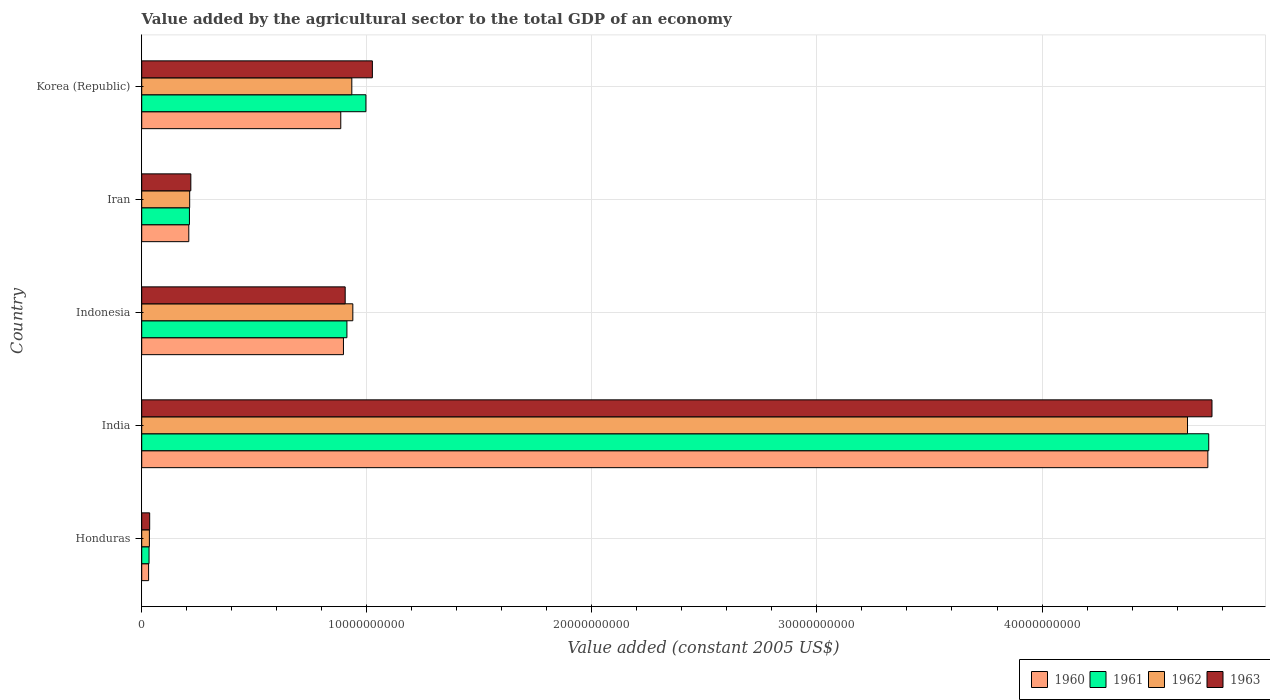Are the number of bars per tick equal to the number of legend labels?
Offer a terse response. Yes. Are the number of bars on each tick of the Y-axis equal?
Offer a terse response. Yes. How many bars are there on the 3rd tick from the top?
Your answer should be very brief. 4. What is the label of the 5th group of bars from the top?
Provide a short and direct response. Honduras. In how many cases, is the number of bars for a given country not equal to the number of legend labels?
Your answer should be very brief. 0. What is the value added by the agricultural sector in 1962 in Indonesia?
Your answer should be compact. 9.38e+09. Across all countries, what is the maximum value added by the agricultural sector in 1963?
Your answer should be compact. 4.76e+1. Across all countries, what is the minimum value added by the agricultural sector in 1963?
Keep it short and to the point. 3.53e+08. In which country was the value added by the agricultural sector in 1961 maximum?
Your response must be concise. India. In which country was the value added by the agricultural sector in 1961 minimum?
Your response must be concise. Honduras. What is the total value added by the agricultural sector in 1960 in the graph?
Your response must be concise. 6.76e+1. What is the difference between the value added by the agricultural sector in 1962 in India and that in Indonesia?
Offer a very short reply. 3.71e+1. What is the difference between the value added by the agricultural sector in 1961 in India and the value added by the agricultural sector in 1962 in Iran?
Offer a terse response. 4.53e+1. What is the average value added by the agricultural sector in 1961 per country?
Ensure brevity in your answer.  1.38e+1. What is the difference between the value added by the agricultural sector in 1960 and value added by the agricultural sector in 1962 in Honduras?
Offer a very short reply. -3.54e+07. What is the ratio of the value added by the agricultural sector in 1961 in Honduras to that in Korea (Republic)?
Give a very brief answer. 0.03. What is the difference between the highest and the second highest value added by the agricultural sector in 1960?
Your answer should be compact. 3.84e+1. What is the difference between the highest and the lowest value added by the agricultural sector in 1961?
Make the answer very short. 4.71e+1. In how many countries, is the value added by the agricultural sector in 1961 greater than the average value added by the agricultural sector in 1961 taken over all countries?
Your response must be concise. 1. What does the 2nd bar from the bottom in Indonesia represents?
Provide a succinct answer. 1961. Is it the case that in every country, the sum of the value added by the agricultural sector in 1960 and value added by the agricultural sector in 1961 is greater than the value added by the agricultural sector in 1963?
Keep it short and to the point. Yes. How many bars are there?
Your answer should be compact. 20. Are all the bars in the graph horizontal?
Provide a short and direct response. Yes. How many countries are there in the graph?
Make the answer very short. 5. Does the graph contain any zero values?
Make the answer very short. No. Does the graph contain grids?
Give a very brief answer. Yes. How many legend labels are there?
Offer a terse response. 4. How are the legend labels stacked?
Offer a terse response. Horizontal. What is the title of the graph?
Keep it short and to the point. Value added by the agricultural sector to the total GDP of an economy. What is the label or title of the X-axis?
Keep it short and to the point. Value added (constant 2005 US$). What is the Value added (constant 2005 US$) of 1960 in Honduras?
Your answer should be very brief. 3.05e+08. What is the Value added (constant 2005 US$) in 1961 in Honduras?
Your response must be concise. 3.25e+08. What is the Value added (constant 2005 US$) of 1962 in Honduras?
Ensure brevity in your answer.  3.41e+08. What is the Value added (constant 2005 US$) of 1963 in Honduras?
Provide a succinct answer. 3.53e+08. What is the Value added (constant 2005 US$) in 1960 in India?
Offer a terse response. 4.74e+1. What is the Value added (constant 2005 US$) of 1961 in India?
Give a very brief answer. 4.74e+1. What is the Value added (constant 2005 US$) of 1962 in India?
Provide a succinct answer. 4.65e+1. What is the Value added (constant 2005 US$) in 1963 in India?
Make the answer very short. 4.76e+1. What is the Value added (constant 2005 US$) of 1960 in Indonesia?
Provide a short and direct response. 8.96e+09. What is the Value added (constant 2005 US$) in 1961 in Indonesia?
Your answer should be very brief. 9.12e+09. What is the Value added (constant 2005 US$) in 1962 in Indonesia?
Ensure brevity in your answer.  9.38e+09. What is the Value added (constant 2005 US$) in 1963 in Indonesia?
Ensure brevity in your answer.  9.04e+09. What is the Value added (constant 2005 US$) of 1960 in Iran?
Your response must be concise. 2.09e+09. What is the Value added (constant 2005 US$) in 1961 in Iran?
Provide a short and direct response. 2.12e+09. What is the Value added (constant 2005 US$) in 1962 in Iran?
Offer a terse response. 2.13e+09. What is the Value added (constant 2005 US$) of 1963 in Iran?
Offer a very short reply. 2.18e+09. What is the Value added (constant 2005 US$) in 1960 in Korea (Republic)?
Provide a succinct answer. 8.84e+09. What is the Value added (constant 2005 US$) in 1961 in Korea (Republic)?
Make the answer very short. 9.96e+09. What is the Value added (constant 2005 US$) of 1962 in Korea (Republic)?
Give a very brief answer. 9.33e+09. What is the Value added (constant 2005 US$) in 1963 in Korea (Republic)?
Give a very brief answer. 1.02e+1. Across all countries, what is the maximum Value added (constant 2005 US$) of 1960?
Your answer should be very brief. 4.74e+1. Across all countries, what is the maximum Value added (constant 2005 US$) of 1961?
Give a very brief answer. 4.74e+1. Across all countries, what is the maximum Value added (constant 2005 US$) in 1962?
Give a very brief answer. 4.65e+1. Across all countries, what is the maximum Value added (constant 2005 US$) of 1963?
Provide a succinct answer. 4.76e+1. Across all countries, what is the minimum Value added (constant 2005 US$) of 1960?
Provide a succinct answer. 3.05e+08. Across all countries, what is the minimum Value added (constant 2005 US$) of 1961?
Provide a short and direct response. 3.25e+08. Across all countries, what is the minimum Value added (constant 2005 US$) in 1962?
Ensure brevity in your answer.  3.41e+08. Across all countries, what is the minimum Value added (constant 2005 US$) in 1963?
Offer a very short reply. 3.53e+08. What is the total Value added (constant 2005 US$) of 1960 in the graph?
Offer a terse response. 6.76e+1. What is the total Value added (constant 2005 US$) in 1961 in the graph?
Give a very brief answer. 6.89e+1. What is the total Value added (constant 2005 US$) in 1962 in the graph?
Provide a short and direct response. 6.76e+1. What is the total Value added (constant 2005 US$) in 1963 in the graph?
Your answer should be compact. 6.94e+1. What is the difference between the Value added (constant 2005 US$) in 1960 in Honduras and that in India?
Provide a succinct answer. -4.71e+1. What is the difference between the Value added (constant 2005 US$) in 1961 in Honduras and that in India?
Make the answer very short. -4.71e+1. What is the difference between the Value added (constant 2005 US$) of 1962 in Honduras and that in India?
Offer a terse response. -4.61e+1. What is the difference between the Value added (constant 2005 US$) of 1963 in Honduras and that in India?
Make the answer very short. -4.72e+1. What is the difference between the Value added (constant 2005 US$) in 1960 in Honduras and that in Indonesia?
Your answer should be very brief. -8.66e+09. What is the difference between the Value added (constant 2005 US$) of 1961 in Honduras and that in Indonesia?
Ensure brevity in your answer.  -8.79e+09. What is the difference between the Value added (constant 2005 US$) in 1962 in Honduras and that in Indonesia?
Give a very brief answer. -9.04e+09. What is the difference between the Value added (constant 2005 US$) of 1963 in Honduras and that in Indonesia?
Make the answer very short. -8.69e+09. What is the difference between the Value added (constant 2005 US$) of 1960 in Honduras and that in Iran?
Provide a succinct answer. -1.79e+09. What is the difference between the Value added (constant 2005 US$) in 1961 in Honduras and that in Iran?
Your response must be concise. -1.79e+09. What is the difference between the Value added (constant 2005 US$) of 1962 in Honduras and that in Iran?
Your answer should be very brief. -1.79e+09. What is the difference between the Value added (constant 2005 US$) of 1963 in Honduras and that in Iran?
Your response must be concise. -1.83e+09. What is the difference between the Value added (constant 2005 US$) of 1960 in Honduras and that in Korea (Republic)?
Provide a short and direct response. -8.54e+09. What is the difference between the Value added (constant 2005 US$) of 1961 in Honduras and that in Korea (Republic)?
Offer a terse response. -9.64e+09. What is the difference between the Value added (constant 2005 US$) in 1962 in Honduras and that in Korea (Republic)?
Your answer should be compact. -8.99e+09. What is the difference between the Value added (constant 2005 US$) in 1963 in Honduras and that in Korea (Republic)?
Make the answer very short. -9.89e+09. What is the difference between the Value added (constant 2005 US$) of 1960 in India and that in Indonesia?
Keep it short and to the point. 3.84e+1. What is the difference between the Value added (constant 2005 US$) of 1961 in India and that in Indonesia?
Offer a terse response. 3.83e+1. What is the difference between the Value added (constant 2005 US$) in 1962 in India and that in Indonesia?
Provide a short and direct response. 3.71e+1. What is the difference between the Value added (constant 2005 US$) of 1963 in India and that in Indonesia?
Provide a short and direct response. 3.85e+1. What is the difference between the Value added (constant 2005 US$) of 1960 in India and that in Iran?
Your answer should be compact. 4.53e+1. What is the difference between the Value added (constant 2005 US$) of 1961 in India and that in Iran?
Provide a succinct answer. 4.53e+1. What is the difference between the Value added (constant 2005 US$) in 1962 in India and that in Iran?
Your answer should be compact. 4.43e+1. What is the difference between the Value added (constant 2005 US$) in 1963 in India and that in Iran?
Ensure brevity in your answer.  4.54e+1. What is the difference between the Value added (constant 2005 US$) in 1960 in India and that in Korea (Republic)?
Make the answer very short. 3.85e+1. What is the difference between the Value added (constant 2005 US$) in 1961 in India and that in Korea (Republic)?
Your answer should be compact. 3.74e+1. What is the difference between the Value added (constant 2005 US$) of 1962 in India and that in Korea (Republic)?
Your response must be concise. 3.71e+1. What is the difference between the Value added (constant 2005 US$) of 1963 in India and that in Korea (Republic)?
Provide a succinct answer. 3.73e+1. What is the difference between the Value added (constant 2005 US$) of 1960 in Indonesia and that in Iran?
Offer a terse response. 6.87e+09. What is the difference between the Value added (constant 2005 US$) in 1961 in Indonesia and that in Iran?
Give a very brief answer. 7.00e+09. What is the difference between the Value added (constant 2005 US$) of 1962 in Indonesia and that in Iran?
Your answer should be compact. 7.25e+09. What is the difference between the Value added (constant 2005 US$) in 1963 in Indonesia and that in Iran?
Your answer should be compact. 6.86e+09. What is the difference between the Value added (constant 2005 US$) in 1960 in Indonesia and that in Korea (Republic)?
Give a very brief answer. 1.19e+08. What is the difference between the Value added (constant 2005 US$) of 1961 in Indonesia and that in Korea (Republic)?
Provide a short and direct response. -8.44e+08. What is the difference between the Value added (constant 2005 US$) of 1962 in Indonesia and that in Korea (Republic)?
Keep it short and to the point. 4.52e+07. What is the difference between the Value added (constant 2005 US$) in 1963 in Indonesia and that in Korea (Republic)?
Ensure brevity in your answer.  -1.21e+09. What is the difference between the Value added (constant 2005 US$) in 1960 in Iran and that in Korea (Republic)?
Provide a short and direct response. -6.75e+09. What is the difference between the Value added (constant 2005 US$) in 1961 in Iran and that in Korea (Republic)?
Ensure brevity in your answer.  -7.84e+09. What is the difference between the Value added (constant 2005 US$) of 1962 in Iran and that in Korea (Republic)?
Your answer should be very brief. -7.20e+09. What is the difference between the Value added (constant 2005 US$) in 1963 in Iran and that in Korea (Republic)?
Make the answer very short. -8.07e+09. What is the difference between the Value added (constant 2005 US$) of 1960 in Honduras and the Value added (constant 2005 US$) of 1961 in India?
Ensure brevity in your answer.  -4.71e+1. What is the difference between the Value added (constant 2005 US$) in 1960 in Honduras and the Value added (constant 2005 US$) in 1962 in India?
Your answer should be very brief. -4.62e+1. What is the difference between the Value added (constant 2005 US$) of 1960 in Honduras and the Value added (constant 2005 US$) of 1963 in India?
Ensure brevity in your answer.  -4.72e+1. What is the difference between the Value added (constant 2005 US$) of 1961 in Honduras and the Value added (constant 2005 US$) of 1962 in India?
Your answer should be compact. -4.61e+1. What is the difference between the Value added (constant 2005 US$) in 1961 in Honduras and the Value added (constant 2005 US$) in 1963 in India?
Give a very brief answer. -4.72e+1. What is the difference between the Value added (constant 2005 US$) of 1962 in Honduras and the Value added (constant 2005 US$) of 1963 in India?
Provide a succinct answer. -4.72e+1. What is the difference between the Value added (constant 2005 US$) in 1960 in Honduras and the Value added (constant 2005 US$) in 1961 in Indonesia?
Offer a terse response. -8.81e+09. What is the difference between the Value added (constant 2005 US$) of 1960 in Honduras and the Value added (constant 2005 US$) of 1962 in Indonesia?
Offer a very short reply. -9.07e+09. What is the difference between the Value added (constant 2005 US$) in 1960 in Honduras and the Value added (constant 2005 US$) in 1963 in Indonesia?
Make the answer very short. -8.73e+09. What is the difference between the Value added (constant 2005 US$) of 1961 in Honduras and the Value added (constant 2005 US$) of 1962 in Indonesia?
Keep it short and to the point. -9.05e+09. What is the difference between the Value added (constant 2005 US$) in 1961 in Honduras and the Value added (constant 2005 US$) in 1963 in Indonesia?
Your answer should be compact. -8.72e+09. What is the difference between the Value added (constant 2005 US$) of 1962 in Honduras and the Value added (constant 2005 US$) of 1963 in Indonesia?
Offer a terse response. -8.70e+09. What is the difference between the Value added (constant 2005 US$) of 1960 in Honduras and the Value added (constant 2005 US$) of 1961 in Iran?
Your answer should be very brief. -1.81e+09. What is the difference between the Value added (constant 2005 US$) in 1960 in Honduras and the Value added (constant 2005 US$) in 1962 in Iran?
Keep it short and to the point. -1.82e+09. What is the difference between the Value added (constant 2005 US$) of 1960 in Honduras and the Value added (constant 2005 US$) of 1963 in Iran?
Provide a short and direct response. -1.88e+09. What is the difference between the Value added (constant 2005 US$) of 1961 in Honduras and the Value added (constant 2005 US$) of 1962 in Iran?
Give a very brief answer. -1.80e+09. What is the difference between the Value added (constant 2005 US$) of 1961 in Honduras and the Value added (constant 2005 US$) of 1963 in Iran?
Provide a short and direct response. -1.86e+09. What is the difference between the Value added (constant 2005 US$) in 1962 in Honduras and the Value added (constant 2005 US$) in 1963 in Iran?
Provide a short and direct response. -1.84e+09. What is the difference between the Value added (constant 2005 US$) in 1960 in Honduras and the Value added (constant 2005 US$) in 1961 in Korea (Republic)?
Give a very brief answer. -9.66e+09. What is the difference between the Value added (constant 2005 US$) in 1960 in Honduras and the Value added (constant 2005 US$) in 1962 in Korea (Republic)?
Keep it short and to the point. -9.03e+09. What is the difference between the Value added (constant 2005 US$) of 1960 in Honduras and the Value added (constant 2005 US$) of 1963 in Korea (Republic)?
Keep it short and to the point. -9.94e+09. What is the difference between the Value added (constant 2005 US$) in 1961 in Honduras and the Value added (constant 2005 US$) in 1962 in Korea (Republic)?
Ensure brevity in your answer.  -9.01e+09. What is the difference between the Value added (constant 2005 US$) of 1961 in Honduras and the Value added (constant 2005 US$) of 1963 in Korea (Republic)?
Provide a succinct answer. -9.92e+09. What is the difference between the Value added (constant 2005 US$) in 1962 in Honduras and the Value added (constant 2005 US$) in 1963 in Korea (Republic)?
Your response must be concise. -9.91e+09. What is the difference between the Value added (constant 2005 US$) in 1960 in India and the Value added (constant 2005 US$) in 1961 in Indonesia?
Offer a very short reply. 3.83e+1. What is the difference between the Value added (constant 2005 US$) of 1960 in India and the Value added (constant 2005 US$) of 1962 in Indonesia?
Offer a terse response. 3.80e+1. What is the difference between the Value added (constant 2005 US$) of 1960 in India and the Value added (constant 2005 US$) of 1963 in Indonesia?
Ensure brevity in your answer.  3.83e+1. What is the difference between the Value added (constant 2005 US$) of 1961 in India and the Value added (constant 2005 US$) of 1962 in Indonesia?
Provide a short and direct response. 3.80e+1. What is the difference between the Value added (constant 2005 US$) in 1961 in India and the Value added (constant 2005 US$) in 1963 in Indonesia?
Your response must be concise. 3.84e+1. What is the difference between the Value added (constant 2005 US$) in 1962 in India and the Value added (constant 2005 US$) in 1963 in Indonesia?
Offer a very short reply. 3.74e+1. What is the difference between the Value added (constant 2005 US$) of 1960 in India and the Value added (constant 2005 US$) of 1961 in Iran?
Your response must be concise. 4.52e+1. What is the difference between the Value added (constant 2005 US$) of 1960 in India and the Value added (constant 2005 US$) of 1962 in Iran?
Offer a very short reply. 4.52e+1. What is the difference between the Value added (constant 2005 US$) in 1960 in India and the Value added (constant 2005 US$) in 1963 in Iran?
Keep it short and to the point. 4.52e+1. What is the difference between the Value added (constant 2005 US$) of 1961 in India and the Value added (constant 2005 US$) of 1962 in Iran?
Ensure brevity in your answer.  4.53e+1. What is the difference between the Value added (constant 2005 US$) in 1961 in India and the Value added (constant 2005 US$) in 1963 in Iran?
Offer a very short reply. 4.52e+1. What is the difference between the Value added (constant 2005 US$) in 1962 in India and the Value added (constant 2005 US$) in 1963 in Iran?
Ensure brevity in your answer.  4.43e+1. What is the difference between the Value added (constant 2005 US$) in 1960 in India and the Value added (constant 2005 US$) in 1961 in Korea (Republic)?
Offer a very short reply. 3.74e+1. What is the difference between the Value added (constant 2005 US$) of 1960 in India and the Value added (constant 2005 US$) of 1962 in Korea (Republic)?
Provide a succinct answer. 3.80e+1. What is the difference between the Value added (constant 2005 US$) of 1960 in India and the Value added (constant 2005 US$) of 1963 in Korea (Republic)?
Provide a succinct answer. 3.71e+1. What is the difference between the Value added (constant 2005 US$) in 1961 in India and the Value added (constant 2005 US$) in 1962 in Korea (Republic)?
Ensure brevity in your answer.  3.81e+1. What is the difference between the Value added (constant 2005 US$) of 1961 in India and the Value added (constant 2005 US$) of 1963 in Korea (Republic)?
Offer a terse response. 3.72e+1. What is the difference between the Value added (constant 2005 US$) in 1962 in India and the Value added (constant 2005 US$) in 1963 in Korea (Republic)?
Offer a terse response. 3.62e+1. What is the difference between the Value added (constant 2005 US$) in 1960 in Indonesia and the Value added (constant 2005 US$) in 1961 in Iran?
Provide a succinct answer. 6.84e+09. What is the difference between the Value added (constant 2005 US$) of 1960 in Indonesia and the Value added (constant 2005 US$) of 1962 in Iran?
Your response must be concise. 6.83e+09. What is the difference between the Value added (constant 2005 US$) of 1960 in Indonesia and the Value added (constant 2005 US$) of 1963 in Iran?
Offer a very short reply. 6.78e+09. What is the difference between the Value added (constant 2005 US$) of 1961 in Indonesia and the Value added (constant 2005 US$) of 1962 in Iran?
Keep it short and to the point. 6.99e+09. What is the difference between the Value added (constant 2005 US$) in 1961 in Indonesia and the Value added (constant 2005 US$) in 1963 in Iran?
Offer a terse response. 6.94e+09. What is the difference between the Value added (constant 2005 US$) in 1962 in Indonesia and the Value added (constant 2005 US$) in 1963 in Iran?
Keep it short and to the point. 7.20e+09. What is the difference between the Value added (constant 2005 US$) of 1960 in Indonesia and the Value added (constant 2005 US$) of 1961 in Korea (Republic)?
Provide a succinct answer. -9.98e+08. What is the difference between the Value added (constant 2005 US$) in 1960 in Indonesia and the Value added (constant 2005 US$) in 1962 in Korea (Republic)?
Provide a short and direct response. -3.71e+08. What is the difference between the Value added (constant 2005 US$) of 1960 in Indonesia and the Value added (constant 2005 US$) of 1963 in Korea (Republic)?
Give a very brief answer. -1.28e+09. What is the difference between the Value added (constant 2005 US$) of 1961 in Indonesia and the Value added (constant 2005 US$) of 1962 in Korea (Republic)?
Offer a very short reply. -2.17e+08. What is the difference between the Value added (constant 2005 US$) in 1961 in Indonesia and the Value added (constant 2005 US$) in 1963 in Korea (Republic)?
Your response must be concise. -1.13e+09. What is the difference between the Value added (constant 2005 US$) in 1962 in Indonesia and the Value added (constant 2005 US$) in 1963 in Korea (Republic)?
Keep it short and to the point. -8.69e+08. What is the difference between the Value added (constant 2005 US$) of 1960 in Iran and the Value added (constant 2005 US$) of 1961 in Korea (Republic)?
Ensure brevity in your answer.  -7.87e+09. What is the difference between the Value added (constant 2005 US$) in 1960 in Iran and the Value added (constant 2005 US$) in 1962 in Korea (Republic)?
Your response must be concise. -7.24e+09. What is the difference between the Value added (constant 2005 US$) of 1960 in Iran and the Value added (constant 2005 US$) of 1963 in Korea (Republic)?
Make the answer very short. -8.16e+09. What is the difference between the Value added (constant 2005 US$) of 1961 in Iran and the Value added (constant 2005 US$) of 1962 in Korea (Republic)?
Offer a terse response. -7.21e+09. What is the difference between the Value added (constant 2005 US$) in 1961 in Iran and the Value added (constant 2005 US$) in 1963 in Korea (Republic)?
Offer a very short reply. -8.13e+09. What is the difference between the Value added (constant 2005 US$) in 1962 in Iran and the Value added (constant 2005 US$) in 1963 in Korea (Republic)?
Offer a terse response. -8.12e+09. What is the average Value added (constant 2005 US$) of 1960 per country?
Your response must be concise. 1.35e+1. What is the average Value added (constant 2005 US$) of 1961 per country?
Provide a succinct answer. 1.38e+1. What is the average Value added (constant 2005 US$) of 1962 per country?
Your answer should be compact. 1.35e+1. What is the average Value added (constant 2005 US$) of 1963 per country?
Offer a terse response. 1.39e+1. What is the difference between the Value added (constant 2005 US$) in 1960 and Value added (constant 2005 US$) in 1961 in Honduras?
Your response must be concise. -1.99e+07. What is the difference between the Value added (constant 2005 US$) of 1960 and Value added (constant 2005 US$) of 1962 in Honduras?
Provide a succinct answer. -3.54e+07. What is the difference between the Value added (constant 2005 US$) of 1960 and Value added (constant 2005 US$) of 1963 in Honduras?
Ensure brevity in your answer.  -4.78e+07. What is the difference between the Value added (constant 2005 US$) of 1961 and Value added (constant 2005 US$) of 1962 in Honduras?
Give a very brief answer. -1.55e+07. What is the difference between the Value added (constant 2005 US$) of 1961 and Value added (constant 2005 US$) of 1963 in Honduras?
Provide a succinct answer. -2.79e+07. What is the difference between the Value added (constant 2005 US$) of 1962 and Value added (constant 2005 US$) of 1963 in Honduras?
Offer a very short reply. -1.24e+07. What is the difference between the Value added (constant 2005 US$) in 1960 and Value added (constant 2005 US$) in 1961 in India?
Your answer should be compact. -3.99e+07. What is the difference between the Value added (constant 2005 US$) of 1960 and Value added (constant 2005 US$) of 1962 in India?
Keep it short and to the point. 9.03e+08. What is the difference between the Value added (constant 2005 US$) in 1960 and Value added (constant 2005 US$) in 1963 in India?
Keep it short and to the point. -1.84e+08. What is the difference between the Value added (constant 2005 US$) of 1961 and Value added (constant 2005 US$) of 1962 in India?
Give a very brief answer. 9.43e+08. What is the difference between the Value added (constant 2005 US$) in 1961 and Value added (constant 2005 US$) in 1963 in India?
Provide a succinct answer. -1.44e+08. What is the difference between the Value added (constant 2005 US$) of 1962 and Value added (constant 2005 US$) of 1963 in India?
Keep it short and to the point. -1.09e+09. What is the difference between the Value added (constant 2005 US$) in 1960 and Value added (constant 2005 US$) in 1961 in Indonesia?
Offer a very short reply. -1.54e+08. What is the difference between the Value added (constant 2005 US$) of 1960 and Value added (constant 2005 US$) of 1962 in Indonesia?
Make the answer very short. -4.16e+08. What is the difference between the Value added (constant 2005 US$) in 1960 and Value added (constant 2005 US$) in 1963 in Indonesia?
Ensure brevity in your answer.  -7.71e+07. What is the difference between the Value added (constant 2005 US$) in 1961 and Value added (constant 2005 US$) in 1962 in Indonesia?
Provide a succinct answer. -2.62e+08. What is the difference between the Value added (constant 2005 US$) in 1961 and Value added (constant 2005 US$) in 1963 in Indonesia?
Your answer should be very brief. 7.71e+07. What is the difference between the Value added (constant 2005 US$) in 1962 and Value added (constant 2005 US$) in 1963 in Indonesia?
Provide a short and direct response. 3.39e+08. What is the difference between the Value added (constant 2005 US$) of 1960 and Value added (constant 2005 US$) of 1961 in Iran?
Your answer should be compact. -2.84e+07. What is the difference between the Value added (constant 2005 US$) in 1960 and Value added (constant 2005 US$) in 1962 in Iran?
Ensure brevity in your answer.  -3.89e+07. What is the difference between the Value added (constant 2005 US$) of 1960 and Value added (constant 2005 US$) of 1963 in Iran?
Keep it short and to the point. -9.02e+07. What is the difference between the Value added (constant 2005 US$) of 1961 and Value added (constant 2005 US$) of 1962 in Iran?
Give a very brief answer. -1.05e+07. What is the difference between the Value added (constant 2005 US$) of 1961 and Value added (constant 2005 US$) of 1963 in Iran?
Offer a terse response. -6.18e+07. What is the difference between the Value added (constant 2005 US$) in 1962 and Value added (constant 2005 US$) in 1963 in Iran?
Your response must be concise. -5.13e+07. What is the difference between the Value added (constant 2005 US$) of 1960 and Value added (constant 2005 US$) of 1961 in Korea (Republic)?
Your response must be concise. -1.12e+09. What is the difference between the Value added (constant 2005 US$) in 1960 and Value added (constant 2005 US$) in 1962 in Korea (Republic)?
Keep it short and to the point. -4.90e+08. What is the difference between the Value added (constant 2005 US$) of 1960 and Value added (constant 2005 US$) of 1963 in Korea (Republic)?
Offer a very short reply. -1.40e+09. What is the difference between the Value added (constant 2005 US$) of 1961 and Value added (constant 2005 US$) of 1962 in Korea (Republic)?
Offer a terse response. 6.27e+08. What is the difference between the Value added (constant 2005 US$) in 1961 and Value added (constant 2005 US$) in 1963 in Korea (Republic)?
Offer a very short reply. -2.87e+08. What is the difference between the Value added (constant 2005 US$) in 1962 and Value added (constant 2005 US$) in 1963 in Korea (Republic)?
Your answer should be very brief. -9.14e+08. What is the ratio of the Value added (constant 2005 US$) in 1960 in Honduras to that in India?
Make the answer very short. 0.01. What is the ratio of the Value added (constant 2005 US$) in 1961 in Honduras to that in India?
Your response must be concise. 0.01. What is the ratio of the Value added (constant 2005 US$) in 1962 in Honduras to that in India?
Provide a short and direct response. 0.01. What is the ratio of the Value added (constant 2005 US$) of 1963 in Honduras to that in India?
Your answer should be compact. 0.01. What is the ratio of the Value added (constant 2005 US$) of 1960 in Honduras to that in Indonesia?
Offer a very short reply. 0.03. What is the ratio of the Value added (constant 2005 US$) in 1961 in Honduras to that in Indonesia?
Make the answer very short. 0.04. What is the ratio of the Value added (constant 2005 US$) of 1962 in Honduras to that in Indonesia?
Your answer should be very brief. 0.04. What is the ratio of the Value added (constant 2005 US$) of 1963 in Honduras to that in Indonesia?
Make the answer very short. 0.04. What is the ratio of the Value added (constant 2005 US$) of 1960 in Honduras to that in Iran?
Your response must be concise. 0.15. What is the ratio of the Value added (constant 2005 US$) in 1961 in Honduras to that in Iran?
Make the answer very short. 0.15. What is the ratio of the Value added (constant 2005 US$) of 1962 in Honduras to that in Iran?
Offer a terse response. 0.16. What is the ratio of the Value added (constant 2005 US$) in 1963 in Honduras to that in Iran?
Give a very brief answer. 0.16. What is the ratio of the Value added (constant 2005 US$) in 1960 in Honduras to that in Korea (Republic)?
Your response must be concise. 0.03. What is the ratio of the Value added (constant 2005 US$) in 1961 in Honduras to that in Korea (Republic)?
Provide a short and direct response. 0.03. What is the ratio of the Value added (constant 2005 US$) of 1962 in Honduras to that in Korea (Republic)?
Provide a succinct answer. 0.04. What is the ratio of the Value added (constant 2005 US$) of 1963 in Honduras to that in Korea (Republic)?
Your answer should be compact. 0.03. What is the ratio of the Value added (constant 2005 US$) of 1960 in India to that in Indonesia?
Provide a short and direct response. 5.28. What is the ratio of the Value added (constant 2005 US$) in 1961 in India to that in Indonesia?
Make the answer very short. 5.2. What is the ratio of the Value added (constant 2005 US$) in 1962 in India to that in Indonesia?
Offer a terse response. 4.95. What is the ratio of the Value added (constant 2005 US$) in 1963 in India to that in Indonesia?
Offer a terse response. 5.26. What is the ratio of the Value added (constant 2005 US$) in 1960 in India to that in Iran?
Offer a terse response. 22.65. What is the ratio of the Value added (constant 2005 US$) of 1961 in India to that in Iran?
Keep it short and to the point. 22.37. What is the ratio of the Value added (constant 2005 US$) in 1962 in India to that in Iran?
Make the answer very short. 21.81. What is the ratio of the Value added (constant 2005 US$) of 1963 in India to that in Iran?
Ensure brevity in your answer.  21.8. What is the ratio of the Value added (constant 2005 US$) in 1960 in India to that in Korea (Republic)?
Provide a short and direct response. 5.36. What is the ratio of the Value added (constant 2005 US$) of 1961 in India to that in Korea (Republic)?
Make the answer very short. 4.76. What is the ratio of the Value added (constant 2005 US$) in 1962 in India to that in Korea (Republic)?
Ensure brevity in your answer.  4.98. What is the ratio of the Value added (constant 2005 US$) of 1963 in India to that in Korea (Republic)?
Offer a very short reply. 4.64. What is the ratio of the Value added (constant 2005 US$) of 1960 in Indonesia to that in Iran?
Keep it short and to the point. 4.29. What is the ratio of the Value added (constant 2005 US$) of 1961 in Indonesia to that in Iran?
Offer a terse response. 4.3. What is the ratio of the Value added (constant 2005 US$) of 1962 in Indonesia to that in Iran?
Offer a terse response. 4.4. What is the ratio of the Value added (constant 2005 US$) in 1963 in Indonesia to that in Iran?
Ensure brevity in your answer.  4.14. What is the ratio of the Value added (constant 2005 US$) in 1960 in Indonesia to that in Korea (Republic)?
Your response must be concise. 1.01. What is the ratio of the Value added (constant 2005 US$) of 1961 in Indonesia to that in Korea (Republic)?
Offer a very short reply. 0.92. What is the ratio of the Value added (constant 2005 US$) in 1962 in Indonesia to that in Korea (Republic)?
Provide a succinct answer. 1. What is the ratio of the Value added (constant 2005 US$) in 1963 in Indonesia to that in Korea (Republic)?
Your answer should be very brief. 0.88. What is the ratio of the Value added (constant 2005 US$) of 1960 in Iran to that in Korea (Republic)?
Your response must be concise. 0.24. What is the ratio of the Value added (constant 2005 US$) of 1961 in Iran to that in Korea (Republic)?
Ensure brevity in your answer.  0.21. What is the ratio of the Value added (constant 2005 US$) in 1962 in Iran to that in Korea (Republic)?
Give a very brief answer. 0.23. What is the ratio of the Value added (constant 2005 US$) of 1963 in Iran to that in Korea (Republic)?
Offer a very short reply. 0.21. What is the difference between the highest and the second highest Value added (constant 2005 US$) of 1960?
Make the answer very short. 3.84e+1. What is the difference between the highest and the second highest Value added (constant 2005 US$) of 1961?
Ensure brevity in your answer.  3.74e+1. What is the difference between the highest and the second highest Value added (constant 2005 US$) of 1962?
Keep it short and to the point. 3.71e+1. What is the difference between the highest and the second highest Value added (constant 2005 US$) in 1963?
Offer a terse response. 3.73e+1. What is the difference between the highest and the lowest Value added (constant 2005 US$) in 1960?
Offer a very short reply. 4.71e+1. What is the difference between the highest and the lowest Value added (constant 2005 US$) in 1961?
Your answer should be compact. 4.71e+1. What is the difference between the highest and the lowest Value added (constant 2005 US$) of 1962?
Provide a succinct answer. 4.61e+1. What is the difference between the highest and the lowest Value added (constant 2005 US$) in 1963?
Give a very brief answer. 4.72e+1. 